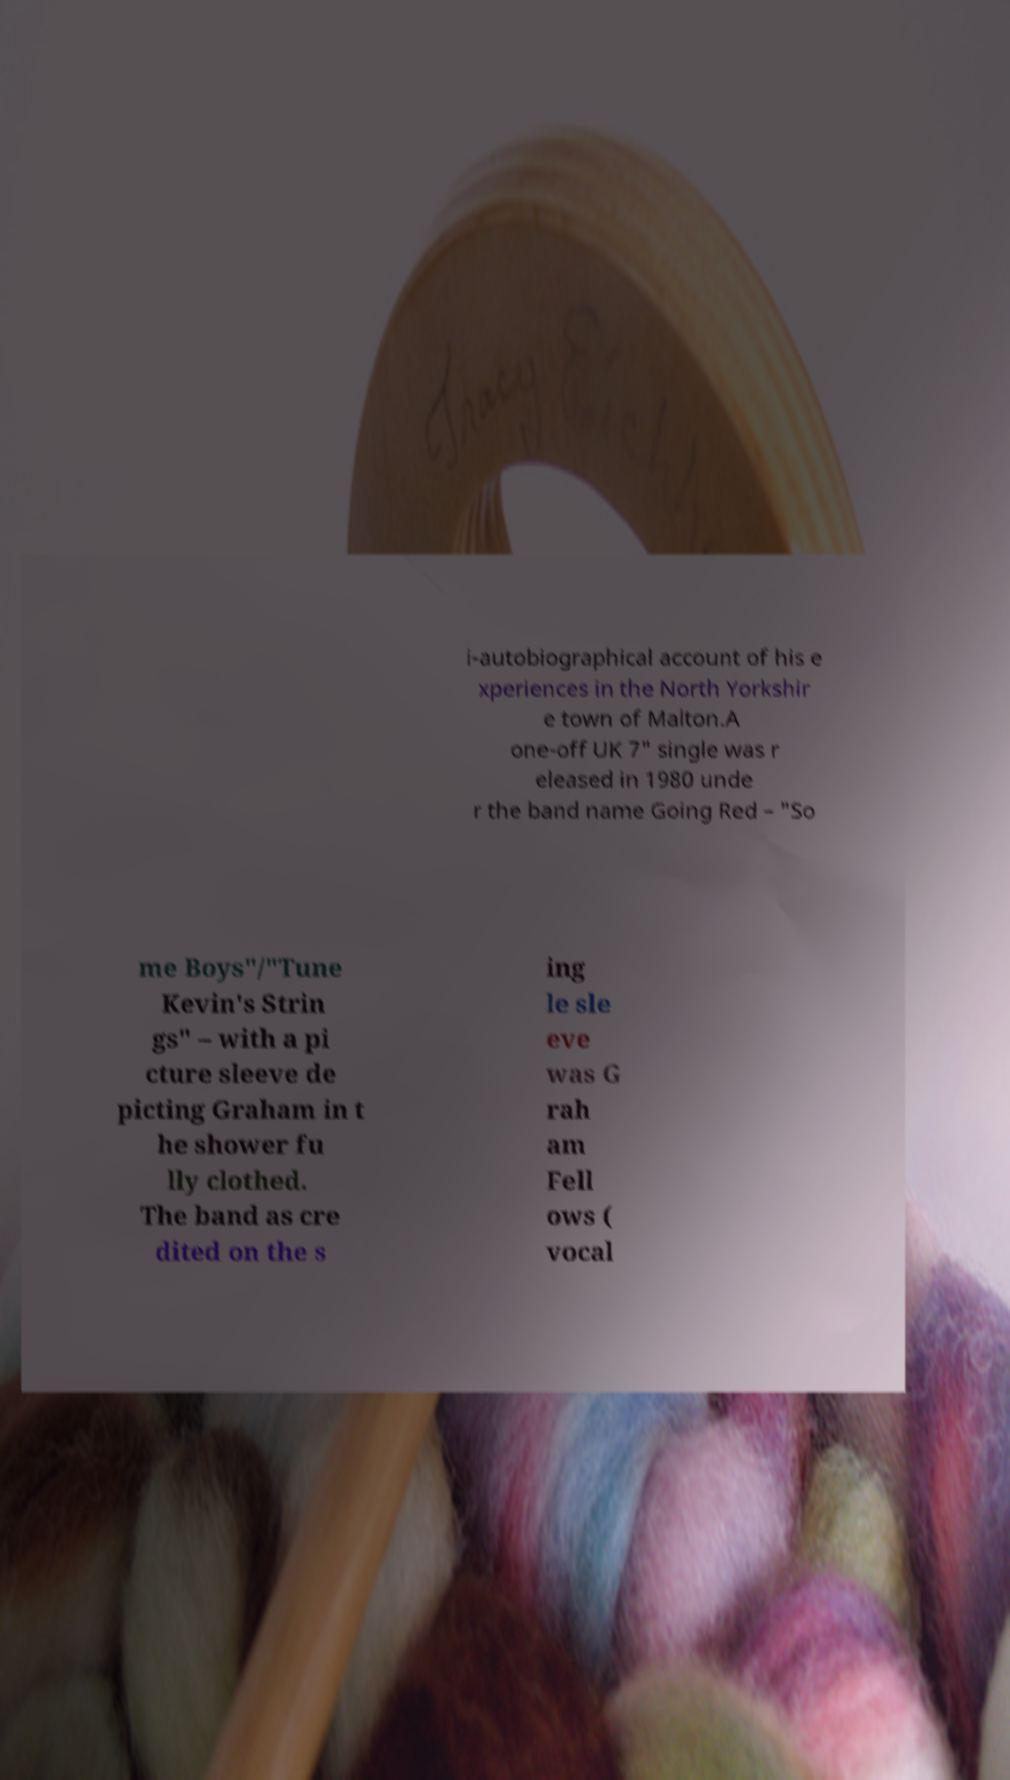I need the written content from this picture converted into text. Can you do that? i-autobiographical account of his e xperiences in the North Yorkshir e town of Malton.A one-off UK 7" single was r eleased in 1980 unde r the band name Going Red – "So me Boys"/"Tune Kevin's Strin gs" – with a pi cture sleeve de picting Graham in t he shower fu lly clothed. The band as cre dited on the s ing le sle eve was G rah am Fell ows ( vocal 